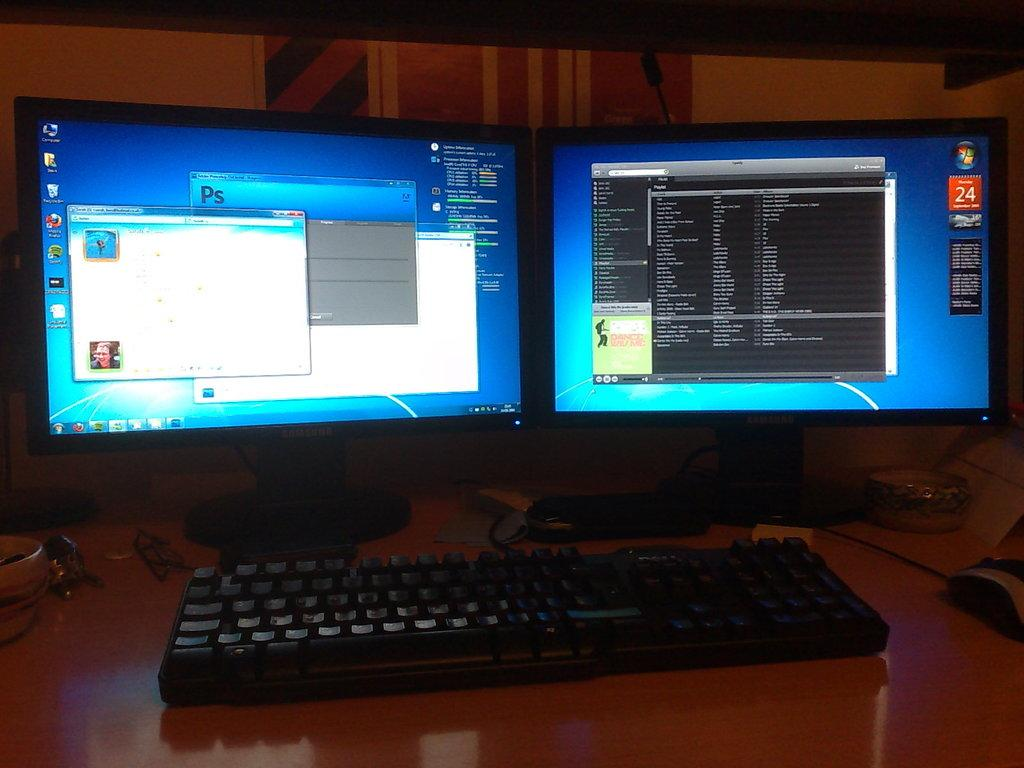<image>
Render a clear and concise summary of the photo. two monitor screens are  open and one has the date at the 24 of september 